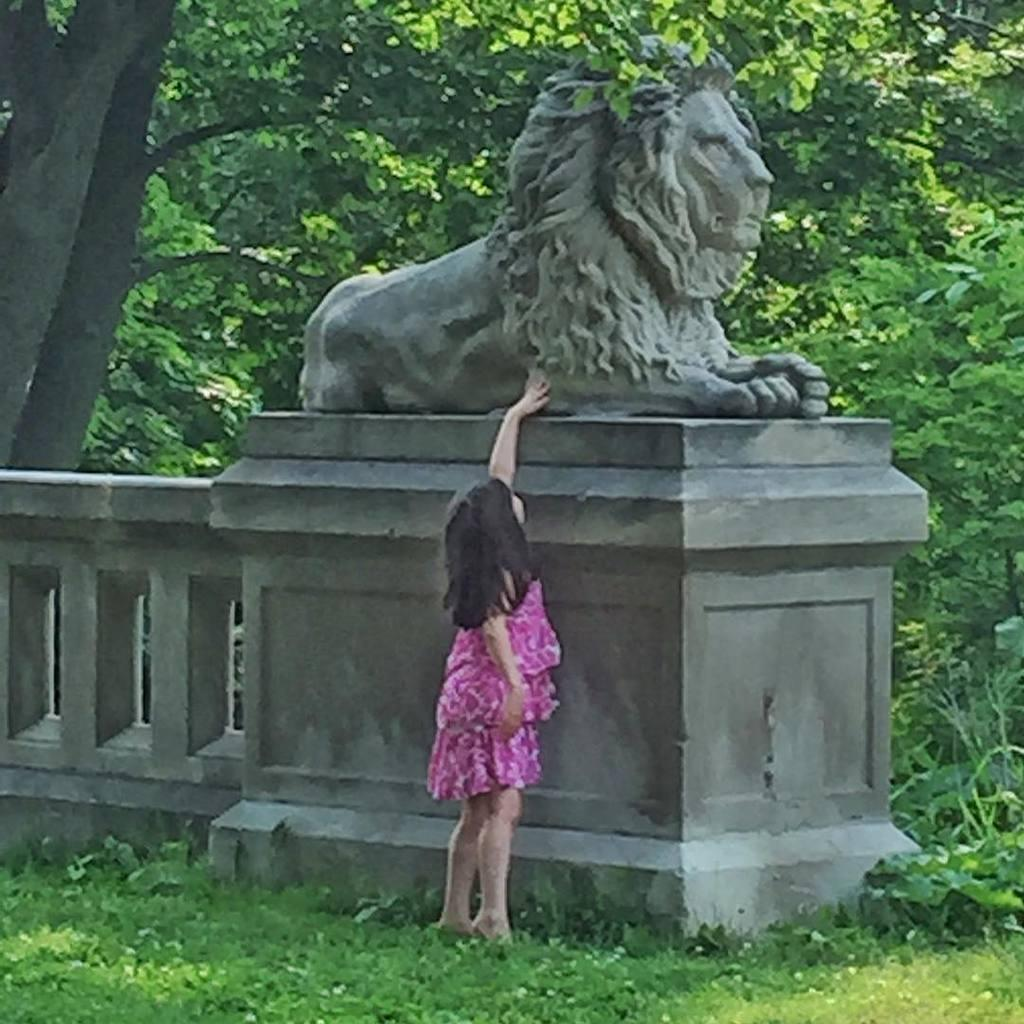What is the main subject of the image? The main subject of the image is a kid. What is the kid wearing? The kid is wearing a pink dress. Where is the kid standing? The kid is standing on a greenery ground. What is the kid doing with her hand? The kid has placed her hand on a statue of a lion. What can be seen in the background of the image? There are trees in the background of the image. What level of drug addiction does the kid show in the image? There is no indication of drug addiction in the image, as it features a kid wearing a pink dress and interacting with a statue of a lion. 